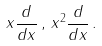<formula> <loc_0><loc_0><loc_500><loc_500>x \frac { d } { d x } \, , \, x ^ { 2 } \frac { d } { d x } \, .</formula> 